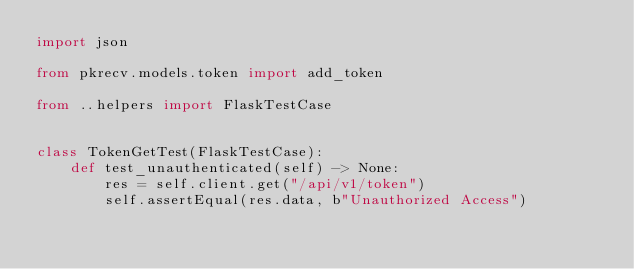Convert code to text. <code><loc_0><loc_0><loc_500><loc_500><_Python_>import json

from pkrecv.models.token import add_token

from ..helpers import FlaskTestCase


class TokenGetTest(FlaskTestCase):
    def test_unauthenticated(self) -> None:
        res = self.client.get("/api/v1/token")
        self.assertEqual(res.data, b"Unauthorized Access")</code> 